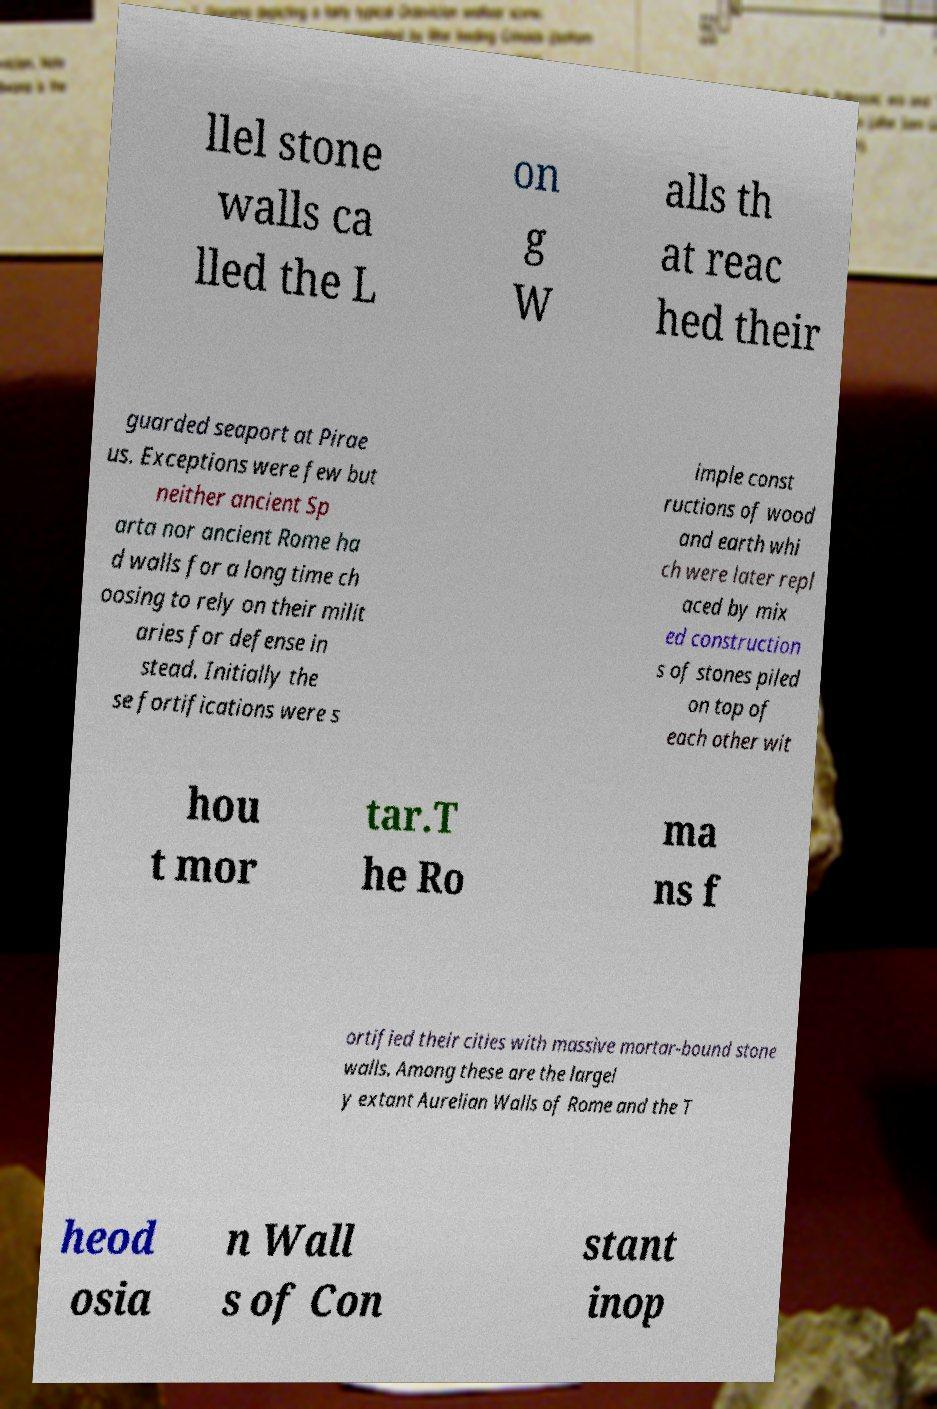Could you assist in decoding the text presented in this image and type it out clearly? llel stone walls ca lled the L on g W alls th at reac hed their guarded seaport at Pirae us. Exceptions were few but neither ancient Sp arta nor ancient Rome ha d walls for a long time ch oosing to rely on their milit aries for defense in stead. Initially the se fortifications were s imple const ructions of wood and earth whi ch were later repl aced by mix ed construction s of stones piled on top of each other wit hou t mor tar.T he Ro ma ns f ortified their cities with massive mortar-bound stone walls. Among these are the largel y extant Aurelian Walls of Rome and the T heod osia n Wall s of Con stant inop 